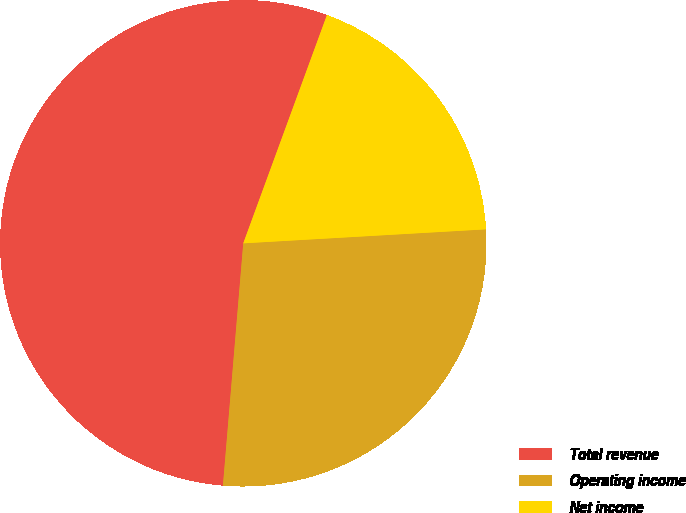<chart> <loc_0><loc_0><loc_500><loc_500><pie_chart><fcel>Total revenue<fcel>Operating income<fcel>Net income<nl><fcel>54.26%<fcel>27.25%<fcel>18.49%<nl></chart> 